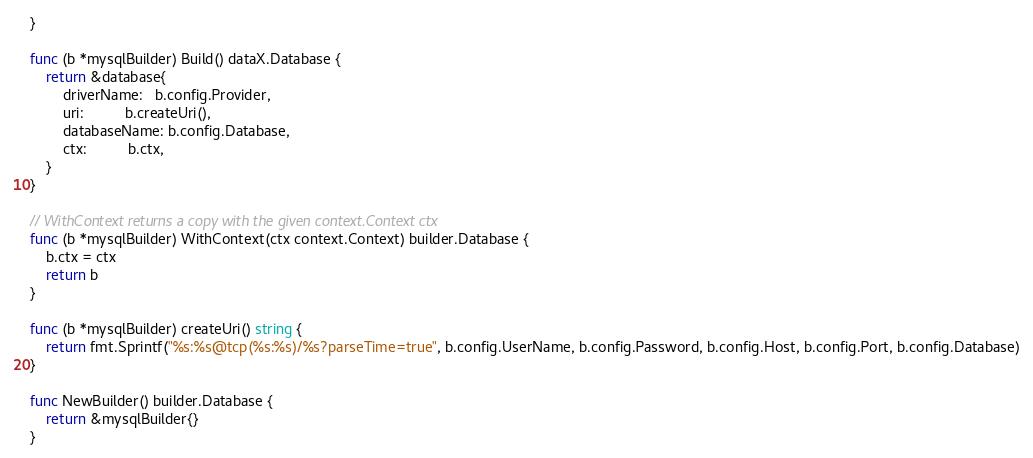Convert code to text. <code><loc_0><loc_0><loc_500><loc_500><_Go_>}

func (b *mysqlBuilder) Build() dataX.Database {
	return &database{
		driverName:   b.config.Provider,
		uri:          b.createUri(),
		databaseName: b.config.Database,
		ctx:          b.ctx,
	}
}

// WithContext returns a copy with the given context.Context ctx
func (b *mysqlBuilder) WithContext(ctx context.Context) builder.Database {
	b.ctx = ctx
	return b
}

func (b *mysqlBuilder) createUri() string {
	return fmt.Sprintf("%s:%s@tcp(%s:%s)/%s?parseTime=true", b.config.UserName, b.config.Password, b.config.Host, b.config.Port, b.config.Database)
}

func NewBuilder() builder.Database {
	return &mysqlBuilder{}
}
</code> 